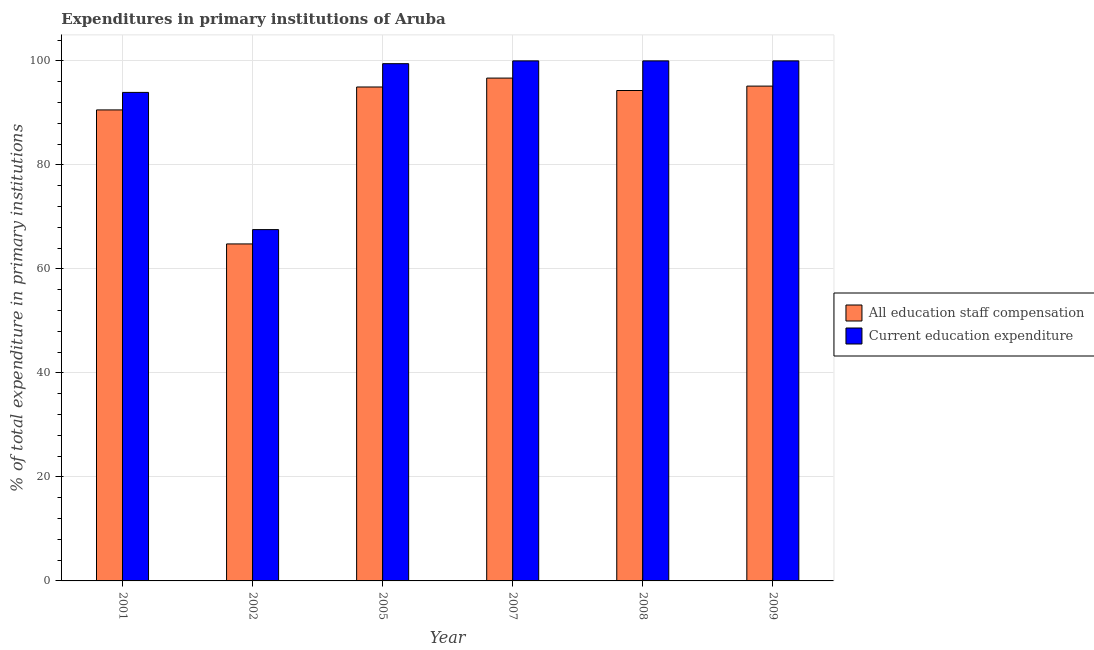How many different coloured bars are there?
Your answer should be very brief. 2. How many groups of bars are there?
Offer a terse response. 6. How many bars are there on the 2nd tick from the right?
Make the answer very short. 2. What is the label of the 6th group of bars from the left?
Ensure brevity in your answer.  2009. In how many cases, is the number of bars for a given year not equal to the number of legend labels?
Offer a very short reply. 0. What is the expenditure in staff compensation in 2007?
Keep it short and to the point. 96.69. Across all years, what is the maximum expenditure in education?
Ensure brevity in your answer.  100. Across all years, what is the minimum expenditure in education?
Your answer should be very brief. 67.55. In which year was the expenditure in education maximum?
Ensure brevity in your answer.  2007. What is the total expenditure in education in the graph?
Your answer should be very brief. 560.95. What is the difference between the expenditure in staff compensation in 2008 and that in 2009?
Your answer should be compact. -0.85. What is the difference between the expenditure in staff compensation in 2005 and the expenditure in education in 2009?
Provide a short and direct response. -0.17. What is the average expenditure in education per year?
Your answer should be very brief. 93.49. What is the ratio of the expenditure in education in 2005 to that in 2009?
Your answer should be very brief. 0.99. Is the expenditure in education in 2001 less than that in 2009?
Offer a very short reply. Yes. Is the difference between the expenditure in education in 2008 and 2009 greater than the difference between the expenditure in staff compensation in 2008 and 2009?
Your answer should be compact. No. What is the difference between the highest and the second highest expenditure in staff compensation?
Provide a short and direct response. 1.54. What is the difference between the highest and the lowest expenditure in education?
Your answer should be compact. 32.45. In how many years, is the expenditure in education greater than the average expenditure in education taken over all years?
Give a very brief answer. 5. Is the sum of the expenditure in education in 2001 and 2009 greater than the maximum expenditure in staff compensation across all years?
Provide a short and direct response. Yes. What does the 1st bar from the left in 2001 represents?
Your response must be concise. All education staff compensation. What does the 1st bar from the right in 2002 represents?
Give a very brief answer. Current education expenditure. Are all the bars in the graph horizontal?
Keep it short and to the point. No. How many years are there in the graph?
Offer a terse response. 6. Are the values on the major ticks of Y-axis written in scientific E-notation?
Provide a succinct answer. No. Does the graph contain grids?
Make the answer very short. Yes. Where does the legend appear in the graph?
Your answer should be very brief. Center right. How many legend labels are there?
Offer a very short reply. 2. What is the title of the graph?
Your answer should be very brief. Expenditures in primary institutions of Aruba. What is the label or title of the Y-axis?
Your answer should be compact. % of total expenditure in primary institutions. What is the % of total expenditure in primary institutions of All education staff compensation in 2001?
Offer a very short reply. 90.57. What is the % of total expenditure in primary institutions of Current education expenditure in 2001?
Provide a short and direct response. 93.94. What is the % of total expenditure in primary institutions in All education staff compensation in 2002?
Give a very brief answer. 64.8. What is the % of total expenditure in primary institutions in Current education expenditure in 2002?
Keep it short and to the point. 67.55. What is the % of total expenditure in primary institutions of All education staff compensation in 2005?
Your response must be concise. 94.98. What is the % of total expenditure in primary institutions in Current education expenditure in 2005?
Provide a succinct answer. 99.46. What is the % of total expenditure in primary institutions in All education staff compensation in 2007?
Give a very brief answer. 96.69. What is the % of total expenditure in primary institutions of Current education expenditure in 2007?
Ensure brevity in your answer.  100. What is the % of total expenditure in primary institutions in All education staff compensation in 2008?
Give a very brief answer. 94.3. What is the % of total expenditure in primary institutions of Current education expenditure in 2008?
Keep it short and to the point. 100. What is the % of total expenditure in primary institutions of All education staff compensation in 2009?
Offer a terse response. 95.15. What is the % of total expenditure in primary institutions of Current education expenditure in 2009?
Your response must be concise. 100. Across all years, what is the maximum % of total expenditure in primary institutions in All education staff compensation?
Your answer should be compact. 96.69. Across all years, what is the maximum % of total expenditure in primary institutions in Current education expenditure?
Offer a very short reply. 100. Across all years, what is the minimum % of total expenditure in primary institutions of All education staff compensation?
Make the answer very short. 64.8. Across all years, what is the minimum % of total expenditure in primary institutions in Current education expenditure?
Offer a very short reply. 67.55. What is the total % of total expenditure in primary institutions in All education staff compensation in the graph?
Your answer should be compact. 536.5. What is the total % of total expenditure in primary institutions of Current education expenditure in the graph?
Keep it short and to the point. 560.95. What is the difference between the % of total expenditure in primary institutions of All education staff compensation in 2001 and that in 2002?
Your answer should be very brief. 25.77. What is the difference between the % of total expenditure in primary institutions of Current education expenditure in 2001 and that in 2002?
Keep it short and to the point. 26.38. What is the difference between the % of total expenditure in primary institutions of All education staff compensation in 2001 and that in 2005?
Offer a very short reply. -4.41. What is the difference between the % of total expenditure in primary institutions of Current education expenditure in 2001 and that in 2005?
Your answer should be compact. -5.52. What is the difference between the % of total expenditure in primary institutions in All education staff compensation in 2001 and that in 2007?
Offer a terse response. -6.12. What is the difference between the % of total expenditure in primary institutions of Current education expenditure in 2001 and that in 2007?
Offer a terse response. -6.06. What is the difference between the % of total expenditure in primary institutions of All education staff compensation in 2001 and that in 2008?
Make the answer very short. -3.73. What is the difference between the % of total expenditure in primary institutions of Current education expenditure in 2001 and that in 2008?
Offer a very short reply. -6.06. What is the difference between the % of total expenditure in primary institutions of All education staff compensation in 2001 and that in 2009?
Make the answer very short. -4.58. What is the difference between the % of total expenditure in primary institutions in Current education expenditure in 2001 and that in 2009?
Your answer should be very brief. -6.06. What is the difference between the % of total expenditure in primary institutions of All education staff compensation in 2002 and that in 2005?
Offer a terse response. -30.18. What is the difference between the % of total expenditure in primary institutions of Current education expenditure in 2002 and that in 2005?
Provide a succinct answer. -31.91. What is the difference between the % of total expenditure in primary institutions of All education staff compensation in 2002 and that in 2007?
Your answer should be very brief. -31.89. What is the difference between the % of total expenditure in primary institutions of Current education expenditure in 2002 and that in 2007?
Your response must be concise. -32.45. What is the difference between the % of total expenditure in primary institutions of All education staff compensation in 2002 and that in 2008?
Give a very brief answer. -29.5. What is the difference between the % of total expenditure in primary institutions in Current education expenditure in 2002 and that in 2008?
Ensure brevity in your answer.  -32.45. What is the difference between the % of total expenditure in primary institutions in All education staff compensation in 2002 and that in 2009?
Provide a short and direct response. -30.35. What is the difference between the % of total expenditure in primary institutions of Current education expenditure in 2002 and that in 2009?
Make the answer very short. -32.45. What is the difference between the % of total expenditure in primary institutions of All education staff compensation in 2005 and that in 2007?
Provide a succinct answer. -1.71. What is the difference between the % of total expenditure in primary institutions of Current education expenditure in 2005 and that in 2007?
Your answer should be very brief. -0.54. What is the difference between the % of total expenditure in primary institutions of All education staff compensation in 2005 and that in 2008?
Your answer should be very brief. 0.68. What is the difference between the % of total expenditure in primary institutions of Current education expenditure in 2005 and that in 2008?
Offer a terse response. -0.54. What is the difference between the % of total expenditure in primary institutions of All education staff compensation in 2005 and that in 2009?
Offer a terse response. -0.17. What is the difference between the % of total expenditure in primary institutions of Current education expenditure in 2005 and that in 2009?
Give a very brief answer. -0.54. What is the difference between the % of total expenditure in primary institutions in All education staff compensation in 2007 and that in 2008?
Your response must be concise. 2.39. What is the difference between the % of total expenditure in primary institutions in All education staff compensation in 2007 and that in 2009?
Ensure brevity in your answer.  1.54. What is the difference between the % of total expenditure in primary institutions in All education staff compensation in 2008 and that in 2009?
Your answer should be compact. -0.85. What is the difference between the % of total expenditure in primary institutions in All education staff compensation in 2001 and the % of total expenditure in primary institutions in Current education expenditure in 2002?
Offer a very short reply. 23.02. What is the difference between the % of total expenditure in primary institutions of All education staff compensation in 2001 and the % of total expenditure in primary institutions of Current education expenditure in 2005?
Your answer should be compact. -8.89. What is the difference between the % of total expenditure in primary institutions in All education staff compensation in 2001 and the % of total expenditure in primary institutions in Current education expenditure in 2007?
Give a very brief answer. -9.43. What is the difference between the % of total expenditure in primary institutions in All education staff compensation in 2001 and the % of total expenditure in primary institutions in Current education expenditure in 2008?
Offer a very short reply. -9.43. What is the difference between the % of total expenditure in primary institutions of All education staff compensation in 2001 and the % of total expenditure in primary institutions of Current education expenditure in 2009?
Your answer should be very brief. -9.43. What is the difference between the % of total expenditure in primary institutions of All education staff compensation in 2002 and the % of total expenditure in primary institutions of Current education expenditure in 2005?
Your answer should be very brief. -34.66. What is the difference between the % of total expenditure in primary institutions in All education staff compensation in 2002 and the % of total expenditure in primary institutions in Current education expenditure in 2007?
Offer a very short reply. -35.2. What is the difference between the % of total expenditure in primary institutions of All education staff compensation in 2002 and the % of total expenditure in primary institutions of Current education expenditure in 2008?
Give a very brief answer. -35.2. What is the difference between the % of total expenditure in primary institutions of All education staff compensation in 2002 and the % of total expenditure in primary institutions of Current education expenditure in 2009?
Provide a short and direct response. -35.2. What is the difference between the % of total expenditure in primary institutions in All education staff compensation in 2005 and the % of total expenditure in primary institutions in Current education expenditure in 2007?
Your response must be concise. -5.02. What is the difference between the % of total expenditure in primary institutions in All education staff compensation in 2005 and the % of total expenditure in primary institutions in Current education expenditure in 2008?
Your answer should be compact. -5.02. What is the difference between the % of total expenditure in primary institutions in All education staff compensation in 2005 and the % of total expenditure in primary institutions in Current education expenditure in 2009?
Provide a short and direct response. -5.02. What is the difference between the % of total expenditure in primary institutions of All education staff compensation in 2007 and the % of total expenditure in primary institutions of Current education expenditure in 2008?
Offer a very short reply. -3.31. What is the difference between the % of total expenditure in primary institutions in All education staff compensation in 2007 and the % of total expenditure in primary institutions in Current education expenditure in 2009?
Make the answer very short. -3.31. What is the difference between the % of total expenditure in primary institutions of All education staff compensation in 2008 and the % of total expenditure in primary institutions of Current education expenditure in 2009?
Your answer should be very brief. -5.7. What is the average % of total expenditure in primary institutions in All education staff compensation per year?
Provide a succinct answer. 89.42. What is the average % of total expenditure in primary institutions in Current education expenditure per year?
Offer a very short reply. 93.49. In the year 2001, what is the difference between the % of total expenditure in primary institutions in All education staff compensation and % of total expenditure in primary institutions in Current education expenditure?
Provide a succinct answer. -3.37. In the year 2002, what is the difference between the % of total expenditure in primary institutions in All education staff compensation and % of total expenditure in primary institutions in Current education expenditure?
Ensure brevity in your answer.  -2.75. In the year 2005, what is the difference between the % of total expenditure in primary institutions in All education staff compensation and % of total expenditure in primary institutions in Current education expenditure?
Ensure brevity in your answer.  -4.48. In the year 2007, what is the difference between the % of total expenditure in primary institutions of All education staff compensation and % of total expenditure in primary institutions of Current education expenditure?
Your answer should be compact. -3.31. In the year 2008, what is the difference between the % of total expenditure in primary institutions of All education staff compensation and % of total expenditure in primary institutions of Current education expenditure?
Offer a terse response. -5.7. In the year 2009, what is the difference between the % of total expenditure in primary institutions of All education staff compensation and % of total expenditure in primary institutions of Current education expenditure?
Offer a very short reply. -4.85. What is the ratio of the % of total expenditure in primary institutions in All education staff compensation in 2001 to that in 2002?
Make the answer very short. 1.4. What is the ratio of the % of total expenditure in primary institutions in Current education expenditure in 2001 to that in 2002?
Give a very brief answer. 1.39. What is the ratio of the % of total expenditure in primary institutions in All education staff compensation in 2001 to that in 2005?
Ensure brevity in your answer.  0.95. What is the ratio of the % of total expenditure in primary institutions of Current education expenditure in 2001 to that in 2005?
Make the answer very short. 0.94. What is the ratio of the % of total expenditure in primary institutions in All education staff compensation in 2001 to that in 2007?
Offer a very short reply. 0.94. What is the ratio of the % of total expenditure in primary institutions in Current education expenditure in 2001 to that in 2007?
Give a very brief answer. 0.94. What is the ratio of the % of total expenditure in primary institutions in All education staff compensation in 2001 to that in 2008?
Your response must be concise. 0.96. What is the ratio of the % of total expenditure in primary institutions in Current education expenditure in 2001 to that in 2008?
Make the answer very short. 0.94. What is the ratio of the % of total expenditure in primary institutions of All education staff compensation in 2001 to that in 2009?
Make the answer very short. 0.95. What is the ratio of the % of total expenditure in primary institutions in Current education expenditure in 2001 to that in 2009?
Provide a succinct answer. 0.94. What is the ratio of the % of total expenditure in primary institutions of All education staff compensation in 2002 to that in 2005?
Ensure brevity in your answer.  0.68. What is the ratio of the % of total expenditure in primary institutions in Current education expenditure in 2002 to that in 2005?
Provide a succinct answer. 0.68. What is the ratio of the % of total expenditure in primary institutions in All education staff compensation in 2002 to that in 2007?
Ensure brevity in your answer.  0.67. What is the ratio of the % of total expenditure in primary institutions of Current education expenditure in 2002 to that in 2007?
Keep it short and to the point. 0.68. What is the ratio of the % of total expenditure in primary institutions in All education staff compensation in 2002 to that in 2008?
Provide a short and direct response. 0.69. What is the ratio of the % of total expenditure in primary institutions of Current education expenditure in 2002 to that in 2008?
Make the answer very short. 0.68. What is the ratio of the % of total expenditure in primary institutions in All education staff compensation in 2002 to that in 2009?
Make the answer very short. 0.68. What is the ratio of the % of total expenditure in primary institutions of Current education expenditure in 2002 to that in 2009?
Your answer should be very brief. 0.68. What is the ratio of the % of total expenditure in primary institutions of All education staff compensation in 2005 to that in 2007?
Keep it short and to the point. 0.98. What is the ratio of the % of total expenditure in primary institutions of All education staff compensation in 2005 to that in 2009?
Your answer should be compact. 1. What is the ratio of the % of total expenditure in primary institutions of Current education expenditure in 2005 to that in 2009?
Keep it short and to the point. 0.99. What is the ratio of the % of total expenditure in primary institutions of All education staff compensation in 2007 to that in 2008?
Provide a succinct answer. 1.03. What is the ratio of the % of total expenditure in primary institutions in Current education expenditure in 2007 to that in 2008?
Keep it short and to the point. 1. What is the ratio of the % of total expenditure in primary institutions in All education staff compensation in 2007 to that in 2009?
Give a very brief answer. 1.02. What is the ratio of the % of total expenditure in primary institutions of Current education expenditure in 2008 to that in 2009?
Your answer should be compact. 1. What is the difference between the highest and the second highest % of total expenditure in primary institutions in All education staff compensation?
Your answer should be very brief. 1.54. What is the difference between the highest and the lowest % of total expenditure in primary institutions of All education staff compensation?
Make the answer very short. 31.89. What is the difference between the highest and the lowest % of total expenditure in primary institutions of Current education expenditure?
Make the answer very short. 32.45. 